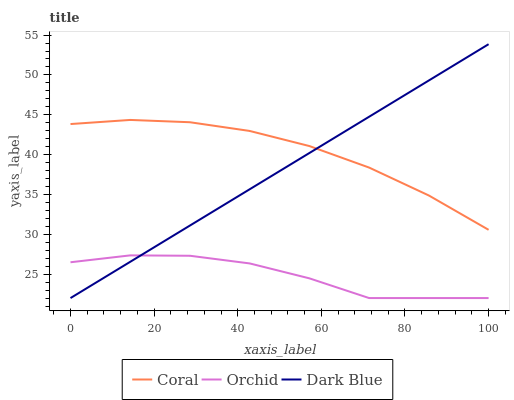Does Orchid have the minimum area under the curve?
Answer yes or no. Yes. Does Coral have the maximum area under the curve?
Answer yes or no. Yes. Does Coral have the minimum area under the curve?
Answer yes or no. No. Does Orchid have the maximum area under the curve?
Answer yes or no. No. Is Dark Blue the smoothest?
Answer yes or no. Yes. Is Orchid the roughest?
Answer yes or no. Yes. Is Coral the smoothest?
Answer yes or no. No. Is Coral the roughest?
Answer yes or no. No. Does Coral have the lowest value?
Answer yes or no. No. Does Dark Blue have the highest value?
Answer yes or no. Yes. Does Coral have the highest value?
Answer yes or no. No. Is Orchid less than Coral?
Answer yes or no. Yes. Is Coral greater than Orchid?
Answer yes or no. Yes. Does Orchid intersect Dark Blue?
Answer yes or no. Yes. Is Orchid less than Dark Blue?
Answer yes or no. No. Is Orchid greater than Dark Blue?
Answer yes or no. No. Does Orchid intersect Coral?
Answer yes or no. No. 